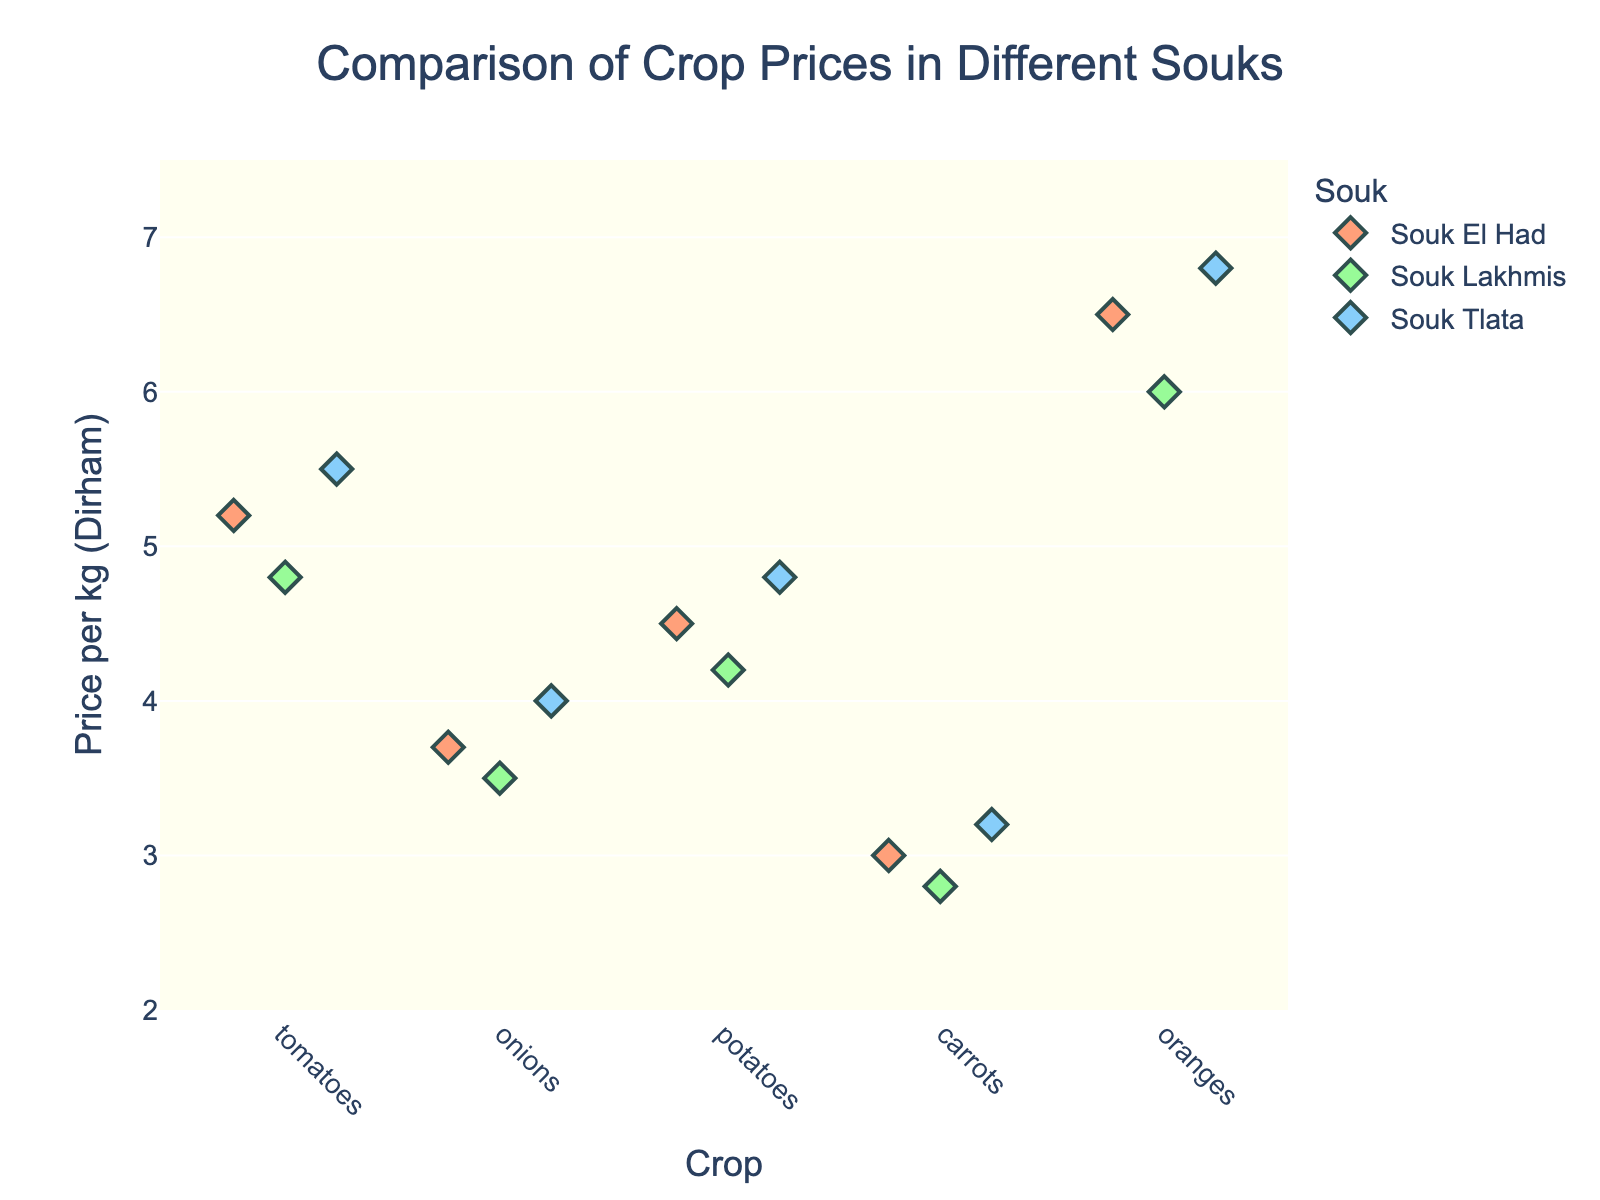What's the title of the figure? The title of the figure is usually displayed at the top. In this case, the title is "Comparison of Crop Prices in Different Souks."
Answer: Comparison of Crop Prices in Different Souks What are the crops listed in the figure? The crops listed in the figure can be read directly from the x-axis labels. They are "tomatoes," "onions," "potatoes," "carrots," and "oranges."
Answer: tomatoes, onions, potatoes, carrots, oranges Which Souk has the highest price for potatoes? To find this, look at the price values for potatoes and see which dot is the highest. Souk Tlata has the highest price for potatoes at 4.8 Dirhams per kg.
Answer: Souk Tlata What is the price range of tomatoes across all souks? Identify the lowest and highest prices for tomatoes. The lowest is 4.8 Dirhams (Souk Lakhmis) and the highest is 5.5 Dirhams (Souk Tlata).
Answer: 4.8 to 5.5 Dirhams How do the prices of carrots compare between Souk El Had and Souk Lakhmis? Look at the carrot prices for Souk El Had and Souk Lakhmis. In Souk El Had, carrots are priced at 3.0 Dirhams per kg, whereas in Souk Lakhmis they are 2.8 Dirhams per kg. Souk Lakhmis price is lower.
Answer: Souk Lakhmis has lower prices What is the average price of onions across all souks? The prices for onions are 3.7 (Souk El Had), 3.5 (Souk Lakhmis), and 4.0 (Souk Tlata). The average is calculated as (3.7 + 3.5 + 4.0) / 3 = 3.73 Dirhams per kg.
Answer: 3.73 Dirhams Which souk has the most expensive crop overall, and what is it? Find the highest price point in the entire plot. The most expensive crop is oranges in Souk Tlata at 6.8 Dirhams per kg.
Answer: Souk Tlata, oranges What is the color representation for Souk Lakhmis in the plot? The colors are mapped to specific souks. Souk Lakhmis is represented by a light green color.
Answer: light green How does the price variability for onions compare to potatoes? Observing the spread of data points for onions and potatoes can show variability. Onions have prices ranging from 3.5 to 4.0 Dirhams, and potatoes range from 4.2 to 4.8 Dirhams. Potatoes have a wider range.
Answer: Potatoes have more variability 